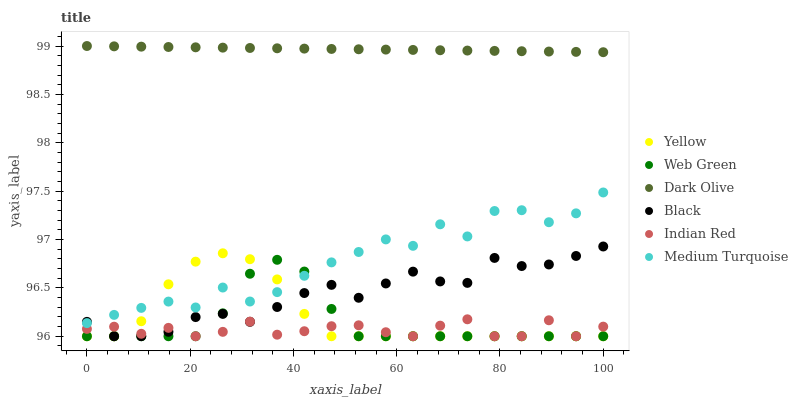Does Indian Red have the minimum area under the curve?
Answer yes or no. Yes. Does Dark Olive have the maximum area under the curve?
Answer yes or no. Yes. Does Web Green have the minimum area under the curve?
Answer yes or no. No. Does Web Green have the maximum area under the curve?
Answer yes or no. No. Is Dark Olive the smoothest?
Answer yes or no. Yes. Is Medium Turquoise the roughest?
Answer yes or no. Yes. Is Web Green the smoothest?
Answer yes or no. No. Is Web Green the roughest?
Answer yes or no. No. Does Web Green have the lowest value?
Answer yes or no. Yes. Does Dark Olive have the lowest value?
Answer yes or no. No. Does Dark Olive have the highest value?
Answer yes or no. Yes. Does Web Green have the highest value?
Answer yes or no. No. Is Indian Red less than Dark Olive?
Answer yes or no. Yes. Is Medium Turquoise greater than Indian Red?
Answer yes or no. Yes. Does Web Green intersect Indian Red?
Answer yes or no. Yes. Is Web Green less than Indian Red?
Answer yes or no. No. Is Web Green greater than Indian Red?
Answer yes or no. No. Does Indian Red intersect Dark Olive?
Answer yes or no. No. 